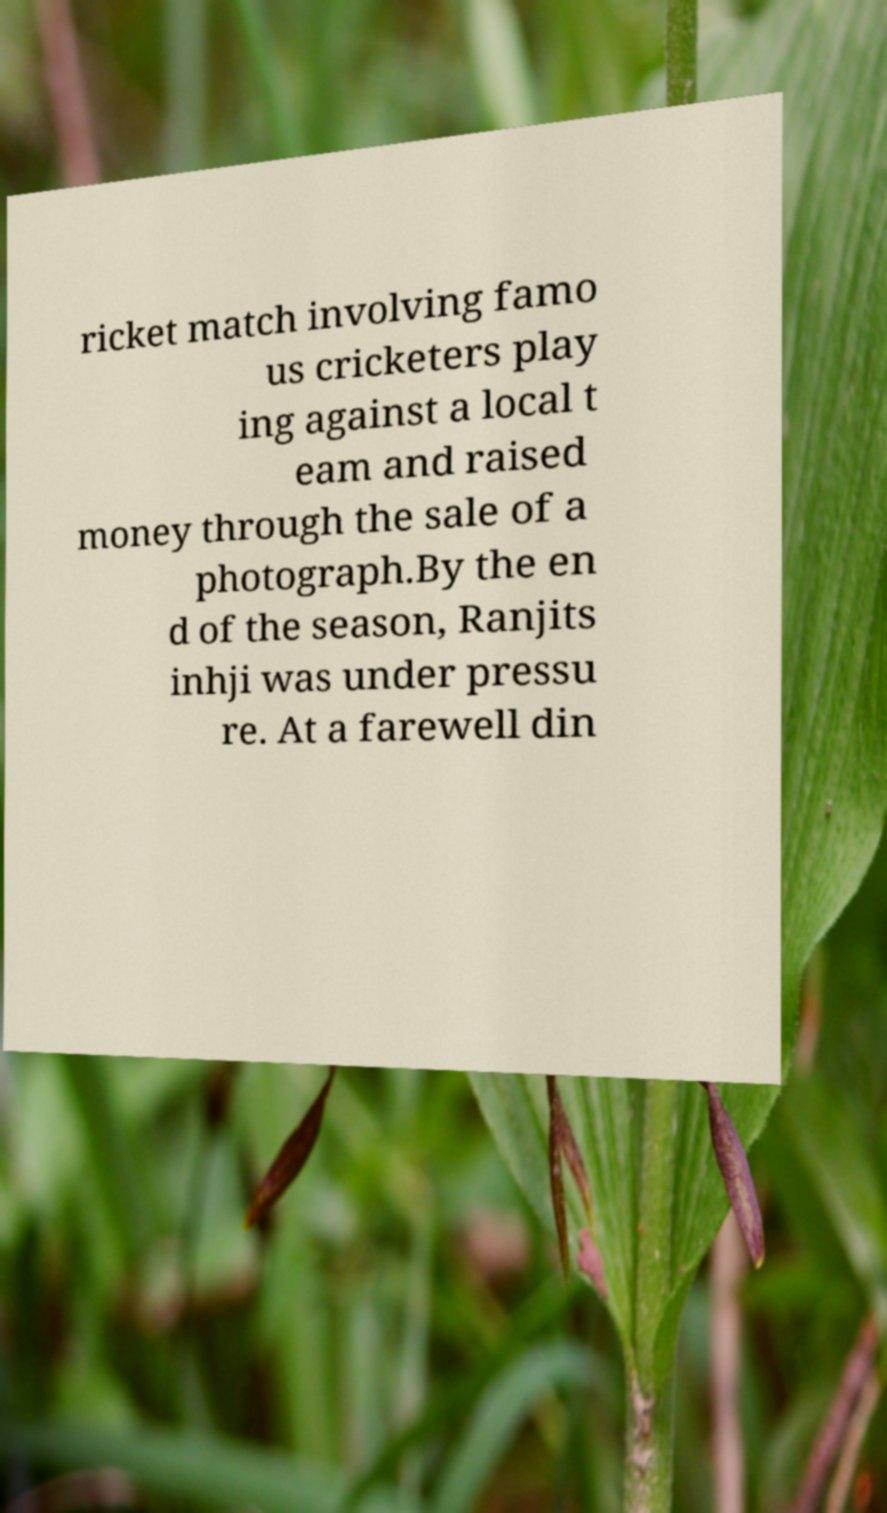Can you read and provide the text displayed in the image?This photo seems to have some interesting text. Can you extract and type it out for me? ricket match involving famo us cricketers play ing against a local t eam and raised money through the sale of a photograph.By the en d of the season, Ranjits inhji was under pressu re. At a farewell din 